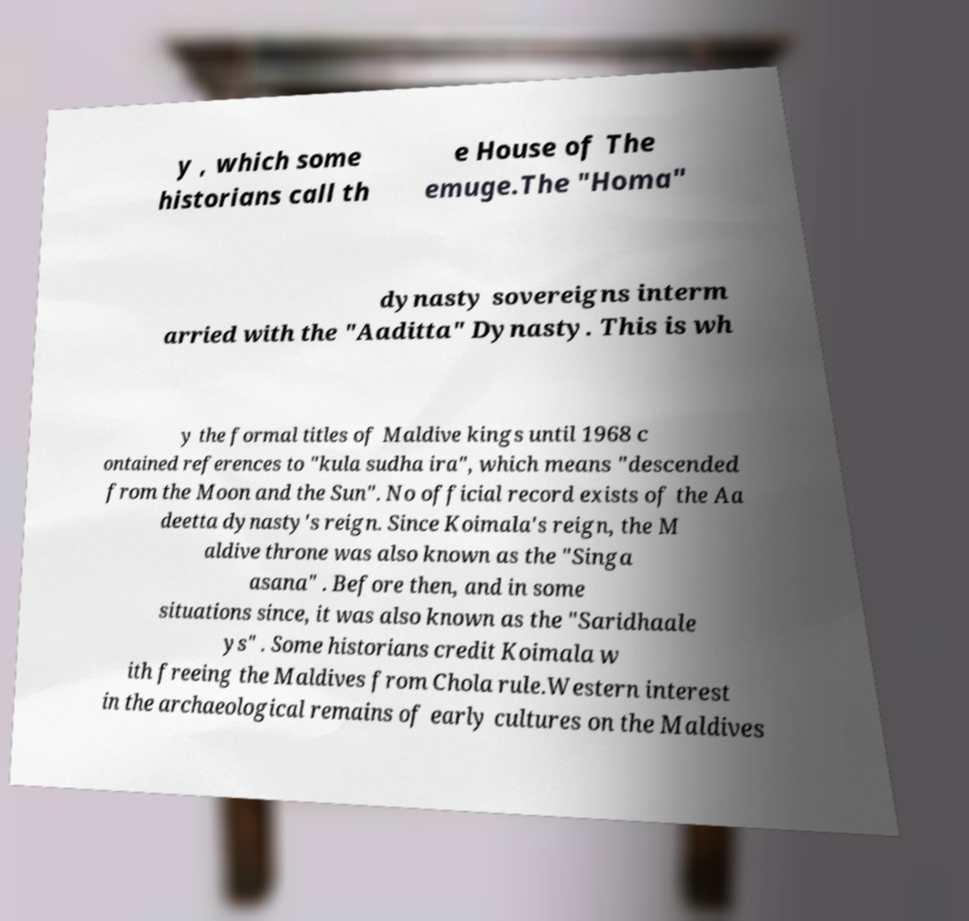What messages or text are displayed in this image? I need them in a readable, typed format. y , which some historians call th e House of The emuge.The "Homa" dynasty sovereigns interm arried with the "Aaditta" Dynasty. This is wh y the formal titles of Maldive kings until 1968 c ontained references to "kula sudha ira", which means "descended from the Moon and the Sun". No official record exists of the Aa deetta dynasty's reign. Since Koimala's reign, the M aldive throne was also known as the "Singa asana" . Before then, and in some situations since, it was also known as the "Saridhaale ys" . Some historians credit Koimala w ith freeing the Maldives from Chola rule.Western interest in the archaeological remains of early cultures on the Maldives 